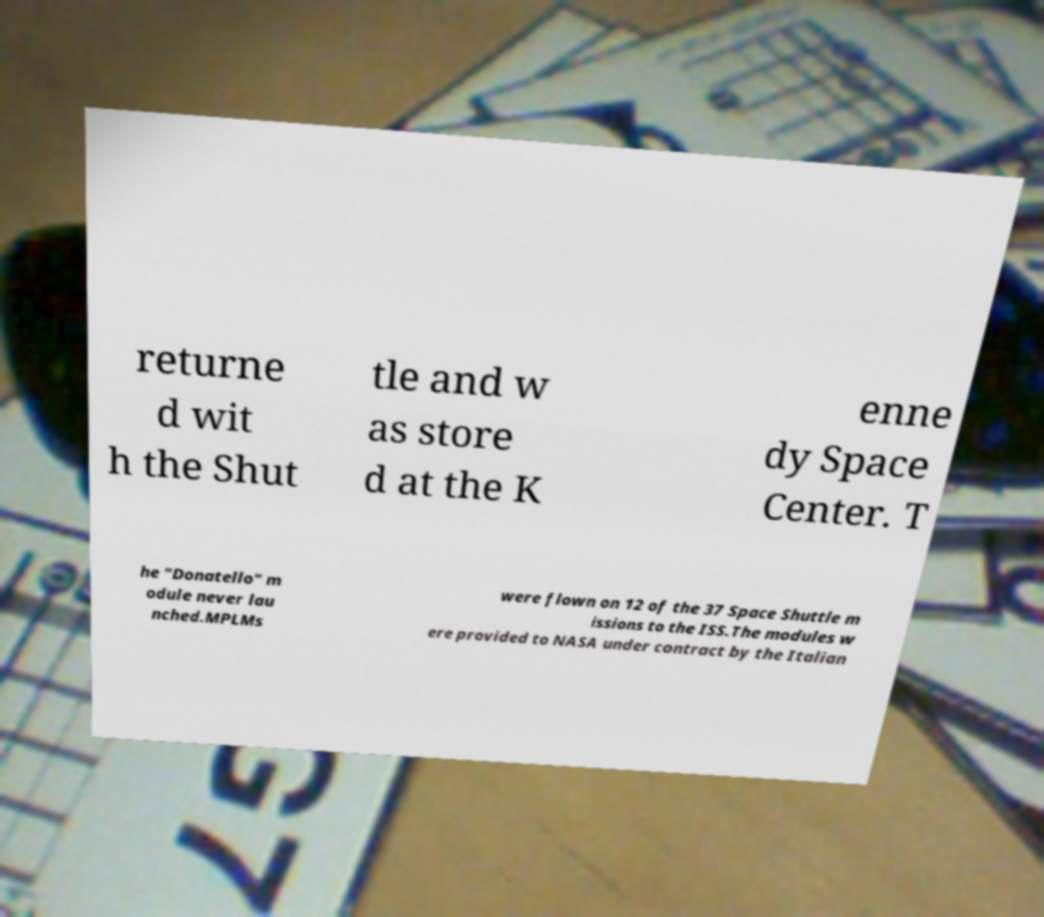Could you assist in decoding the text presented in this image and type it out clearly? returne d wit h the Shut tle and w as store d at the K enne dy Space Center. T he "Donatello" m odule never lau nched.MPLMs were flown on 12 of the 37 Space Shuttle m issions to the ISS.The modules w ere provided to NASA under contract by the Italian 